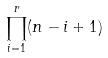<formula> <loc_0><loc_0><loc_500><loc_500>\prod _ { i = 1 } ^ { r } ( n - i + 1 )</formula> 